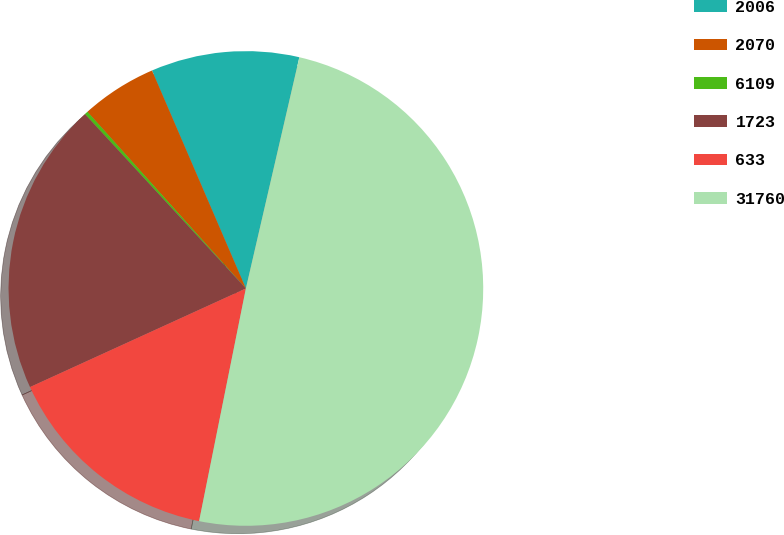Convert chart to OTSL. <chart><loc_0><loc_0><loc_500><loc_500><pie_chart><fcel>2006<fcel>2070<fcel>6109<fcel>1723<fcel>633<fcel>31760<nl><fcel>10.09%<fcel>5.16%<fcel>0.23%<fcel>19.95%<fcel>15.02%<fcel>49.53%<nl></chart> 